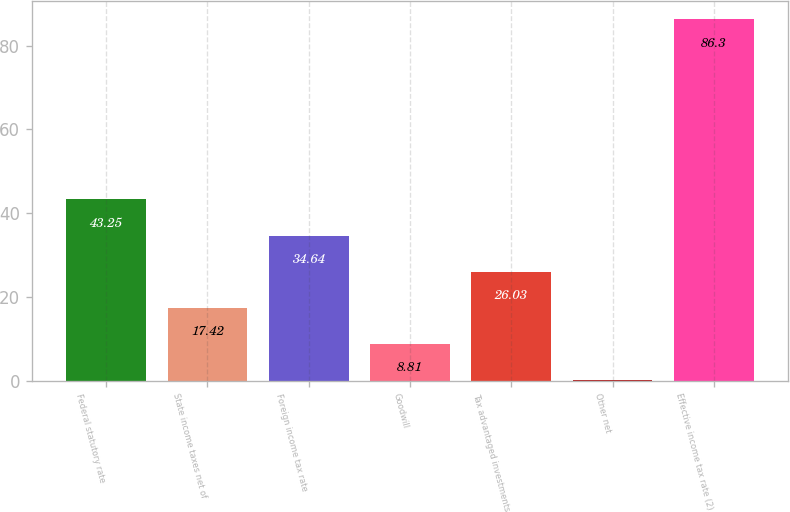Convert chart. <chart><loc_0><loc_0><loc_500><loc_500><bar_chart><fcel>Federal statutory rate<fcel>State income taxes net of<fcel>Foreign income tax rate<fcel>Goodwill<fcel>Tax advantaged investments<fcel>Other net<fcel>Effective income tax rate (2)<nl><fcel>43.25<fcel>17.42<fcel>34.64<fcel>8.81<fcel>26.03<fcel>0.2<fcel>86.3<nl></chart> 